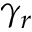Convert formula to latex. <formula><loc_0><loc_0><loc_500><loc_500>\gamma _ { r }</formula> 